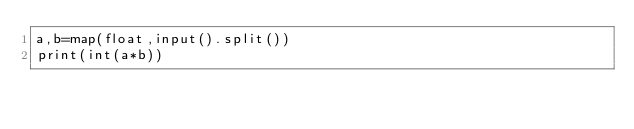<code> <loc_0><loc_0><loc_500><loc_500><_Python_>a,b=map(float,input().split())
print(int(a*b))</code> 